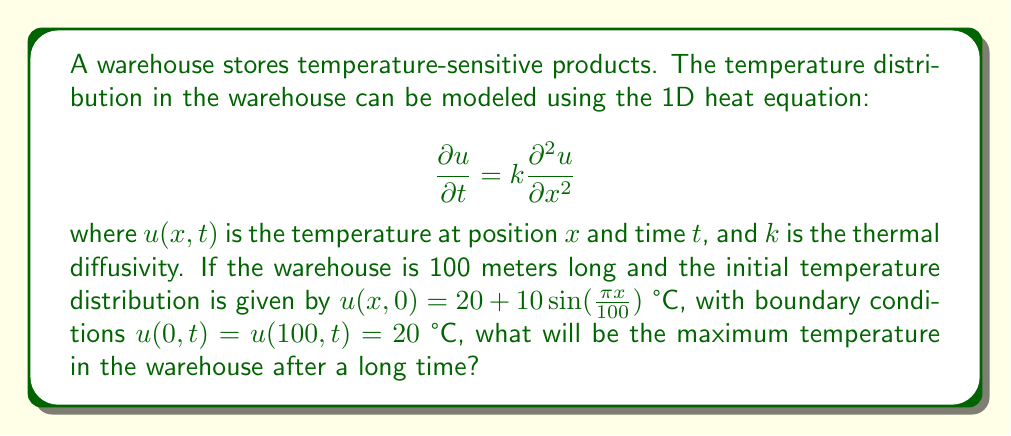Can you answer this question? To solve this problem, we need to consider the steady-state solution of the heat equation, which represents the temperature distribution after a long time. The steps are as follows:

1) In steady-state, the temperature doesn't change with time, so $\frac{\partial u}{\partial t} = 0$. The heat equation reduces to:

   $$0 = k\frac{\partial^2 u}{\partial x^2}$$

2) This implies that $\frac{\partial^2 u}{\partial x^2} = 0$, which means the steady-state solution is linear:

   $$u(x) = ax + b$$

3) Using the boundary conditions:
   At $x = 0$: $u(0) = b = 20$
   At $x = 100$: $u(100) = 100a + 20 = 20$

4) From the second condition, we get $a = 0$.

5) Therefore, the steady-state solution is:

   $$u(x) = 20$$

6) This means that after a long time, the temperature will be uniform throughout the warehouse at 20°C.

7) The maximum temperature will also be 20°C.
Answer: 20°C 